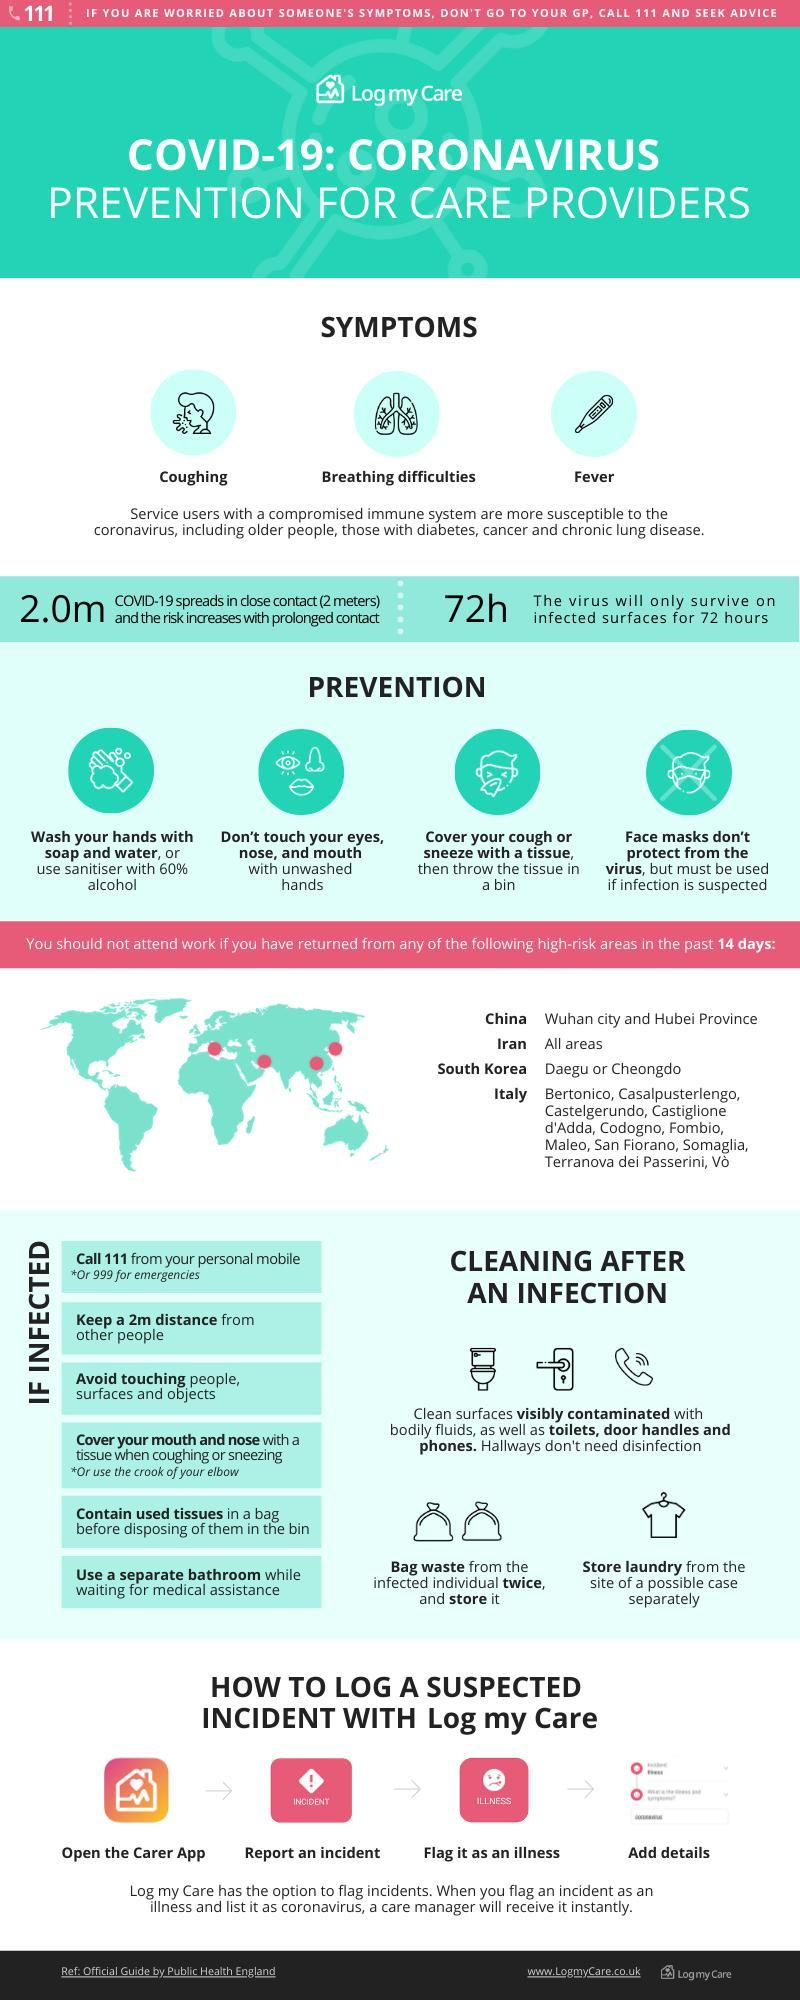What are the symptoms of COVID-19 other than fever & coughing?
Answer the question with a short phrase. Breathing difficulties Which region in South Korea is considered to be the high-risk area? Daegu or Cheongdo 